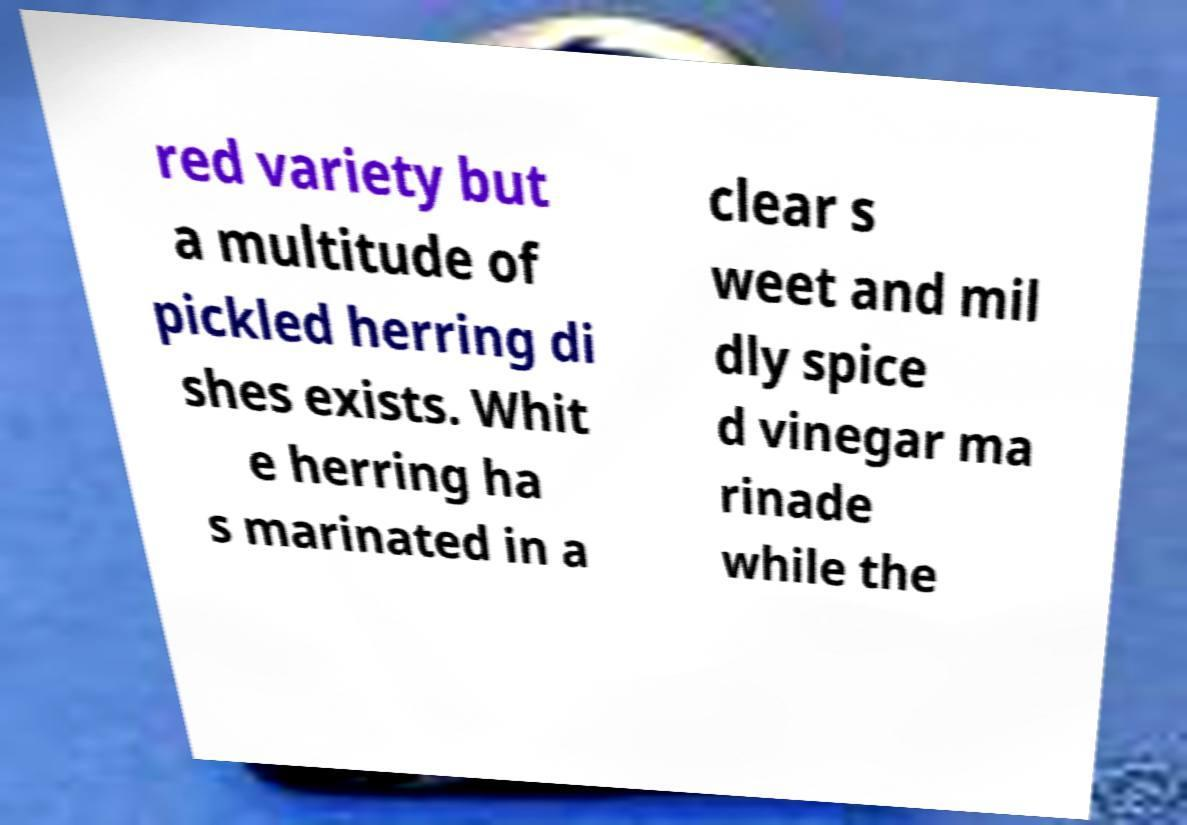For documentation purposes, I need the text within this image transcribed. Could you provide that? red variety but a multitude of pickled herring di shes exists. Whit e herring ha s marinated in a clear s weet and mil dly spice d vinegar ma rinade while the 